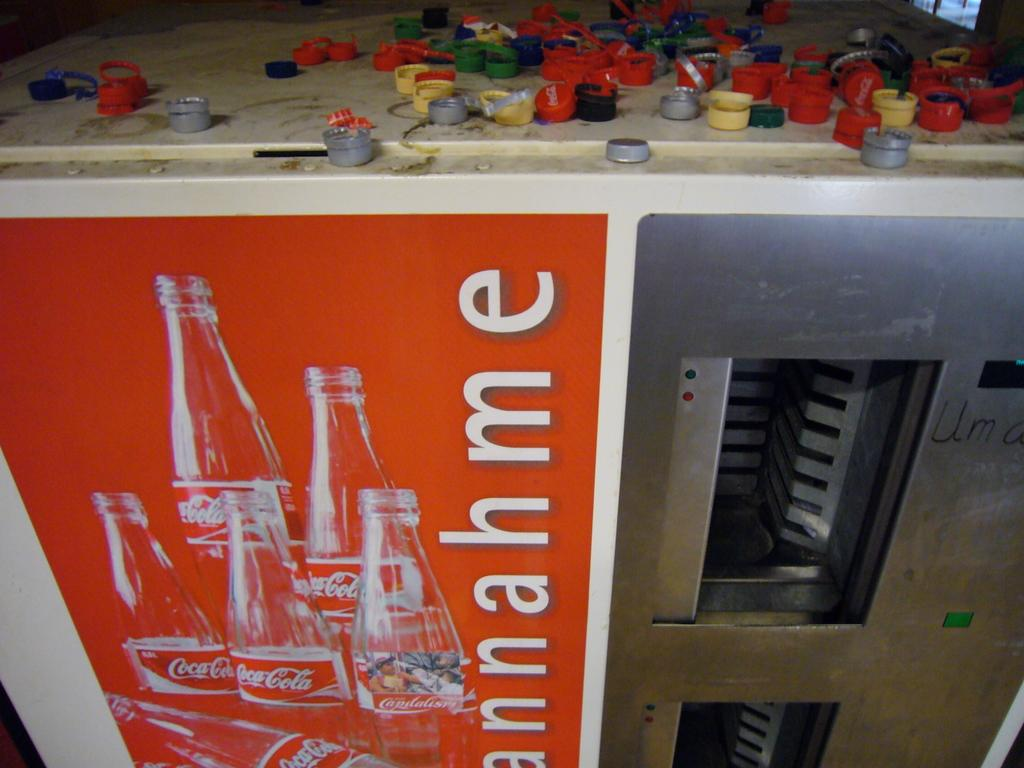<image>
Give a short and clear explanation of the subsequent image. The Coca-Cola case has bottle caps thrown all over the top. 